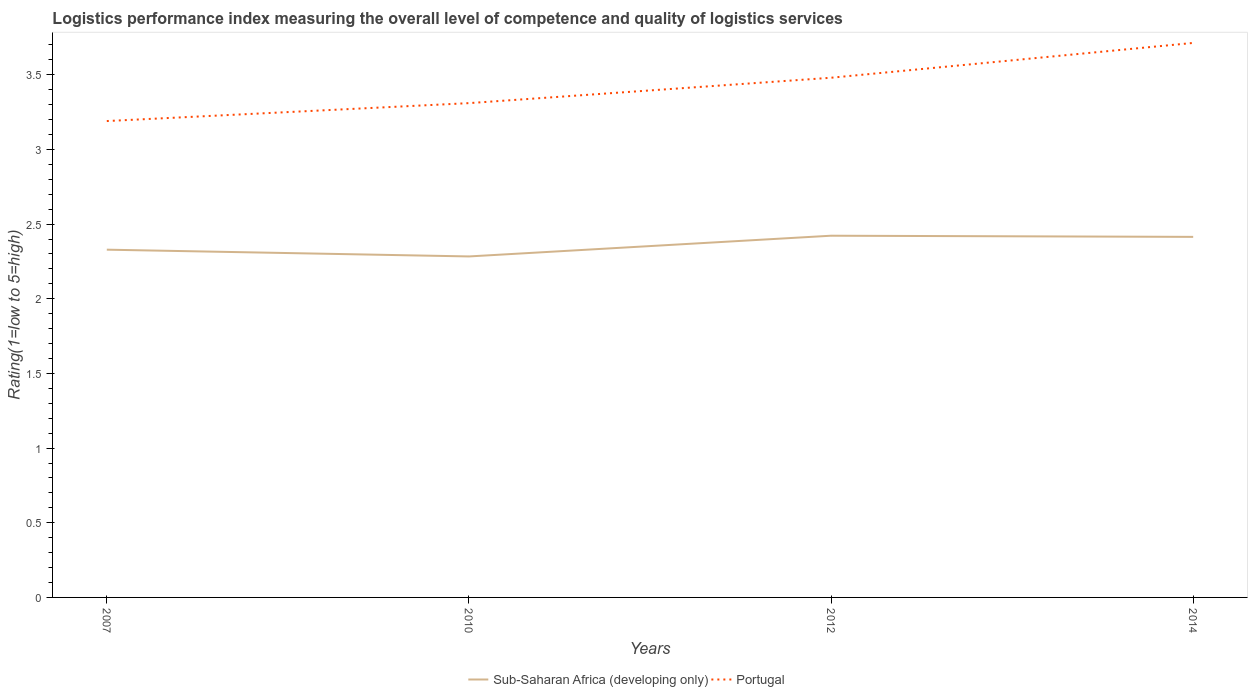Across all years, what is the maximum Logistic performance index in Portugal?
Offer a terse response. 3.19. In which year was the Logistic performance index in Sub-Saharan Africa (developing only) maximum?
Offer a very short reply. 2010. What is the total Logistic performance index in Portugal in the graph?
Your answer should be compact. -0.23. What is the difference between the highest and the second highest Logistic performance index in Sub-Saharan Africa (developing only)?
Provide a succinct answer. 0.14. What is the difference between the highest and the lowest Logistic performance index in Portugal?
Your answer should be compact. 2. How many years are there in the graph?
Keep it short and to the point. 4. What is the difference between two consecutive major ticks on the Y-axis?
Keep it short and to the point. 0.5. Are the values on the major ticks of Y-axis written in scientific E-notation?
Offer a terse response. No. Does the graph contain any zero values?
Provide a succinct answer. No. What is the title of the graph?
Your response must be concise. Logistics performance index measuring the overall level of competence and quality of logistics services. Does "Botswana" appear as one of the legend labels in the graph?
Ensure brevity in your answer.  No. What is the label or title of the X-axis?
Give a very brief answer. Years. What is the label or title of the Y-axis?
Your answer should be compact. Rating(1=low to 5=high). What is the Rating(1=low to 5=high) in Sub-Saharan Africa (developing only) in 2007?
Keep it short and to the point. 2.33. What is the Rating(1=low to 5=high) of Portugal in 2007?
Offer a terse response. 3.19. What is the Rating(1=low to 5=high) of Sub-Saharan Africa (developing only) in 2010?
Give a very brief answer. 2.28. What is the Rating(1=low to 5=high) of Portugal in 2010?
Offer a terse response. 3.31. What is the Rating(1=low to 5=high) of Sub-Saharan Africa (developing only) in 2012?
Offer a terse response. 2.42. What is the Rating(1=low to 5=high) of Portugal in 2012?
Your answer should be very brief. 3.48. What is the Rating(1=low to 5=high) of Sub-Saharan Africa (developing only) in 2014?
Keep it short and to the point. 2.41. What is the Rating(1=low to 5=high) in Portugal in 2014?
Ensure brevity in your answer.  3.71. Across all years, what is the maximum Rating(1=low to 5=high) in Sub-Saharan Africa (developing only)?
Make the answer very short. 2.42. Across all years, what is the maximum Rating(1=low to 5=high) of Portugal?
Your answer should be compact. 3.71. Across all years, what is the minimum Rating(1=low to 5=high) in Sub-Saharan Africa (developing only)?
Give a very brief answer. 2.28. Across all years, what is the minimum Rating(1=low to 5=high) in Portugal?
Ensure brevity in your answer.  3.19. What is the total Rating(1=low to 5=high) of Sub-Saharan Africa (developing only) in the graph?
Ensure brevity in your answer.  9.45. What is the total Rating(1=low to 5=high) in Portugal in the graph?
Offer a very short reply. 13.69. What is the difference between the Rating(1=low to 5=high) in Sub-Saharan Africa (developing only) in 2007 and that in 2010?
Keep it short and to the point. 0.05. What is the difference between the Rating(1=low to 5=high) of Portugal in 2007 and that in 2010?
Keep it short and to the point. -0.12. What is the difference between the Rating(1=low to 5=high) of Sub-Saharan Africa (developing only) in 2007 and that in 2012?
Your response must be concise. -0.09. What is the difference between the Rating(1=low to 5=high) of Portugal in 2007 and that in 2012?
Make the answer very short. -0.29. What is the difference between the Rating(1=low to 5=high) of Sub-Saharan Africa (developing only) in 2007 and that in 2014?
Your response must be concise. -0.09. What is the difference between the Rating(1=low to 5=high) in Portugal in 2007 and that in 2014?
Ensure brevity in your answer.  -0.52. What is the difference between the Rating(1=low to 5=high) of Sub-Saharan Africa (developing only) in 2010 and that in 2012?
Ensure brevity in your answer.  -0.14. What is the difference between the Rating(1=low to 5=high) in Portugal in 2010 and that in 2012?
Offer a very short reply. -0.17. What is the difference between the Rating(1=low to 5=high) of Sub-Saharan Africa (developing only) in 2010 and that in 2014?
Your answer should be compact. -0.13. What is the difference between the Rating(1=low to 5=high) of Portugal in 2010 and that in 2014?
Offer a terse response. -0.4. What is the difference between the Rating(1=low to 5=high) in Sub-Saharan Africa (developing only) in 2012 and that in 2014?
Provide a short and direct response. 0.01. What is the difference between the Rating(1=low to 5=high) of Portugal in 2012 and that in 2014?
Offer a very short reply. -0.23. What is the difference between the Rating(1=low to 5=high) of Sub-Saharan Africa (developing only) in 2007 and the Rating(1=low to 5=high) of Portugal in 2010?
Your answer should be very brief. -0.98. What is the difference between the Rating(1=low to 5=high) of Sub-Saharan Africa (developing only) in 2007 and the Rating(1=low to 5=high) of Portugal in 2012?
Offer a terse response. -1.15. What is the difference between the Rating(1=low to 5=high) in Sub-Saharan Africa (developing only) in 2007 and the Rating(1=low to 5=high) in Portugal in 2014?
Provide a short and direct response. -1.38. What is the difference between the Rating(1=low to 5=high) in Sub-Saharan Africa (developing only) in 2010 and the Rating(1=low to 5=high) in Portugal in 2012?
Provide a succinct answer. -1.2. What is the difference between the Rating(1=low to 5=high) of Sub-Saharan Africa (developing only) in 2010 and the Rating(1=low to 5=high) of Portugal in 2014?
Your response must be concise. -1.43. What is the difference between the Rating(1=low to 5=high) in Sub-Saharan Africa (developing only) in 2012 and the Rating(1=low to 5=high) in Portugal in 2014?
Keep it short and to the point. -1.29. What is the average Rating(1=low to 5=high) of Sub-Saharan Africa (developing only) per year?
Offer a terse response. 2.36. What is the average Rating(1=low to 5=high) of Portugal per year?
Provide a short and direct response. 3.42. In the year 2007, what is the difference between the Rating(1=low to 5=high) of Sub-Saharan Africa (developing only) and Rating(1=low to 5=high) of Portugal?
Make the answer very short. -0.86. In the year 2010, what is the difference between the Rating(1=low to 5=high) in Sub-Saharan Africa (developing only) and Rating(1=low to 5=high) in Portugal?
Your answer should be very brief. -1.03. In the year 2012, what is the difference between the Rating(1=low to 5=high) of Sub-Saharan Africa (developing only) and Rating(1=low to 5=high) of Portugal?
Offer a very short reply. -1.06. In the year 2014, what is the difference between the Rating(1=low to 5=high) in Sub-Saharan Africa (developing only) and Rating(1=low to 5=high) in Portugal?
Give a very brief answer. -1.3. What is the ratio of the Rating(1=low to 5=high) of Sub-Saharan Africa (developing only) in 2007 to that in 2010?
Provide a short and direct response. 1.02. What is the ratio of the Rating(1=low to 5=high) of Portugal in 2007 to that in 2010?
Ensure brevity in your answer.  0.96. What is the ratio of the Rating(1=low to 5=high) of Sub-Saharan Africa (developing only) in 2007 to that in 2012?
Offer a terse response. 0.96. What is the ratio of the Rating(1=low to 5=high) of Portugal in 2007 to that in 2012?
Offer a very short reply. 0.92. What is the ratio of the Rating(1=low to 5=high) of Sub-Saharan Africa (developing only) in 2007 to that in 2014?
Your answer should be very brief. 0.96. What is the ratio of the Rating(1=low to 5=high) of Portugal in 2007 to that in 2014?
Offer a terse response. 0.86. What is the ratio of the Rating(1=low to 5=high) of Sub-Saharan Africa (developing only) in 2010 to that in 2012?
Give a very brief answer. 0.94. What is the ratio of the Rating(1=low to 5=high) in Portugal in 2010 to that in 2012?
Make the answer very short. 0.95. What is the ratio of the Rating(1=low to 5=high) of Sub-Saharan Africa (developing only) in 2010 to that in 2014?
Provide a short and direct response. 0.95. What is the ratio of the Rating(1=low to 5=high) in Portugal in 2010 to that in 2014?
Keep it short and to the point. 0.89. What is the ratio of the Rating(1=low to 5=high) in Portugal in 2012 to that in 2014?
Provide a short and direct response. 0.94. What is the difference between the highest and the second highest Rating(1=low to 5=high) of Sub-Saharan Africa (developing only)?
Offer a terse response. 0.01. What is the difference between the highest and the second highest Rating(1=low to 5=high) in Portugal?
Offer a very short reply. 0.23. What is the difference between the highest and the lowest Rating(1=low to 5=high) in Sub-Saharan Africa (developing only)?
Provide a short and direct response. 0.14. What is the difference between the highest and the lowest Rating(1=low to 5=high) in Portugal?
Keep it short and to the point. 0.52. 